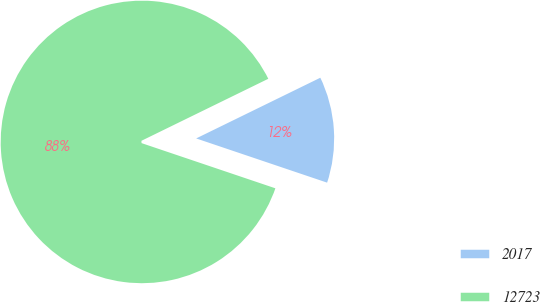<chart> <loc_0><loc_0><loc_500><loc_500><pie_chart><fcel>2017<fcel>12723<nl><fcel>12.42%<fcel>87.58%<nl></chart> 